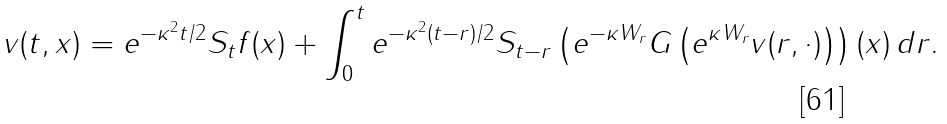<formula> <loc_0><loc_0><loc_500><loc_500>v ( t , x ) = e ^ { - \kappa ^ { 2 } t / 2 } S _ { t } f ( x ) + \int _ { 0 } ^ { t } e ^ { - \kappa ^ { 2 } ( t - r ) / 2 } S _ { t - r } \left ( e ^ { - \kappa W _ { r } } G \left ( e ^ { \kappa W _ { r } } v ( r , \cdot ) \right ) \right ) ( x ) \, d r .</formula> 